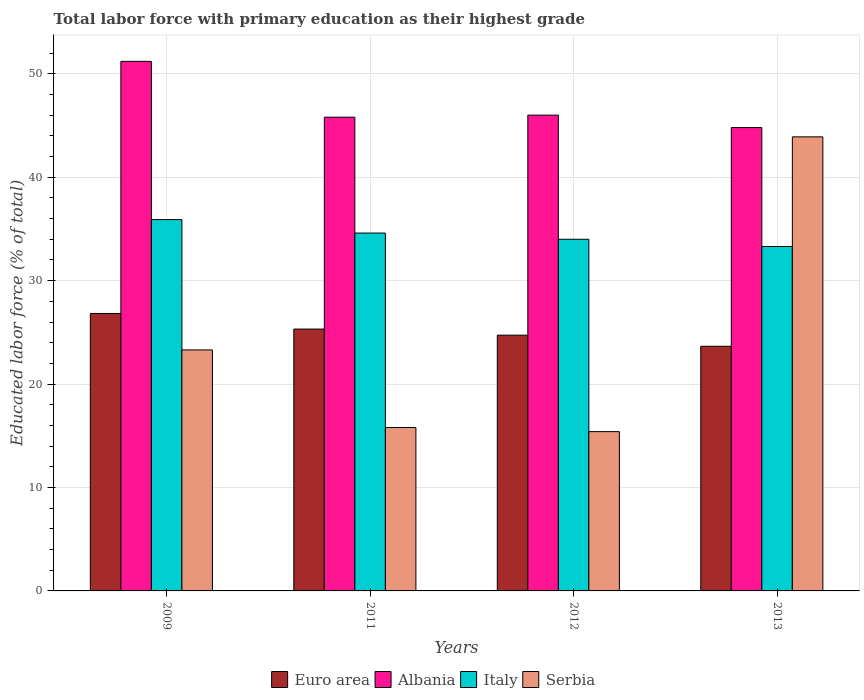How many groups of bars are there?
Make the answer very short. 4. Are the number of bars per tick equal to the number of legend labels?
Provide a succinct answer. Yes. What is the label of the 3rd group of bars from the left?
Your answer should be very brief. 2012. What is the percentage of total labor force with primary education in Serbia in 2009?
Offer a very short reply. 23.3. Across all years, what is the maximum percentage of total labor force with primary education in Serbia?
Give a very brief answer. 43.9. Across all years, what is the minimum percentage of total labor force with primary education in Albania?
Offer a very short reply. 44.8. What is the total percentage of total labor force with primary education in Serbia in the graph?
Provide a succinct answer. 98.4. What is the difference between the percentage of total labor force with primary education in Albania in 2012 and that in 2013?
Your answer should be compact. 1.2. What is the difference between the percentage of total labor force with primary education in Albania in 2011 and the percentage of total labor force with primary education in Euro area in 2009?
Provide a succinct answer. 18.97. What is the average percentage of total labor force with primary education in Italy per year?
Make the answer very short. 34.45. In the year 2009, what is the difference between the percentage of total labor force with primary education in Euro area and percentage of total labor force with primary education in Serbia?
Provide a short and direct response. 3.53. What is the ratio of the percentage of total labor force with primary education in Albania in 2012 to that in 2013?
Ensure brevity in your answer.  1.03. What is the difference between the highest and the second highest percentage of total labor force with primary education in Euro area?
Offer a terse response. 1.51. What is the difference between the highest and the lowest percentage of total labor force with primary education in Serbia?
Ensure brevity in your answer.  28.5. Is it the case that in every year, the sum of the percentage of total labor force with primary education in Serbia and percentage of total labor force with primary education in Euro area is greater than the sum of percentage of total labor force with primary education in Albania and percentage of total labor force with primary education in Italy?
Offer a very short reply. Yes. What does the 3rd bar from the left in 2012 represents?
Give a very brief answer. Italy. What does the 3rd bar from the right in 2012 represents?
Make the answer very short. Albania. Is it the case that in every year, the sum of the percentage of total labor force with primary education in Italy and percentage of total labor force with primary education in Albania is greater than the percentage of total labor force with primary education in Euro area?
Offer a terse response. Yes. How many bars are there?
Your answer should be compact. 16. What is the difference between two consecutive major ticks on the Y-axis?
Give a very brief answer. 10. Does the graph contain any zero values?
Make the answer very short. No. Does the graph contain grids?
Offer a very short reply. Yes. Where does the legend appear in the graph?
Give a very brief answer. Bottom center. How many legend labels are there?
Your answer should be compact. 4. How are the legend labels stacked?
Your answer should be compact. Horizontal. What is the title of the graph?
Give a very brief answer. Total labor force with primary education as their highest grade. Does "Low income" appear as one of the legend labels in the graph?
Keep it short and to the point. No. What is the label or title of the Y-axis?
Ensure brevity in your answer.  Educated labor force (% of total). What is the Educated labor force (% of total) of Euro area in 2009?
Ensure brevity in your answer.  26.83. What is the Educated labor force (% of total) of Albania in 2009?
Make the answer very short. 51.2. What is the Educated labor force (% of total) of Italy in 2009?
Provide a succinct answer. 35.9. What is the Educated labor force (% of total) in Serbia in 2009?
Your answer should be very brief. 23.3. What is the Educated labor force (% of total) of Euro area in 2011?
Provide a succinct answer. 25.32. What is the Educated labor force (% of total) in Albania in 2011?
Your response must be concise. 45.8. What is the Educated labor force (% of total) in Italy in 2011?
Give a very brief answer. 34.6. What is the Educated labor force (% of total) of Serbia in 2011?
Offer a terse response. 15.8. What is the Educated labor force (% of total) of Euro area in 2012?
Provide a short and direct response. 24.73. What is the Educated labor force (% of total) in Italy in 2012?
Give a very brief answer. 34. What is the Educated labor force (% of total) of Serbia in 2012?
Offer a terse response. 15.4. What is the Educated labor force (% of total) in Euro area in 2013?
Keep it short and to the point. 23.65. What is the Educated labor force (% of total) of Albania in 2013?
Your answer should be very brief. 44.8. What is the Educated labor force (% of total) of Italy in 2013?
Offer a very short reply. 33.3. What is the Educated labor force (% of total) of Serbia in 2013?
Your response must be concise. 43.9. Across all years, what is the maximum Educated labor force (% of total) in Euro area?
Give a very brief answer. 26.83. Across all years, what is the maximum Educated labor force (% of total) in Albania?
Your answer should be very brief. 51.2. Across all years, what is the maximum Educated labor force (% of total) of Italy?
Your answer should be compact. 35.9. Across all years, what is the maximum Educated labor force (% of total) of Serbia?
Offer a very short reply. 43.9. Across all years, what is the minimum Educated labor force (% of total) of Euro area?
Provide a short and direct response. 23.65. Across all years, what is the minimum Educated labor force (% of total) of Albania?
Make the answer very short. 44.8. Across all years, what is the minimum Educated labor force (% of total) in Italy?
Offer a terse response. 33.3. Across all years, what is the minimum Educated labor force (% of total) in Serbia?
Ensure brevity in your answer.  15.4. What is the total Educated labor force (% of total) in Euro area in the graph?
Offer a very short reply. 100.52. What is the total Educated labor force (% of total) in Albania in the graph?
Your response must be concise. 187.8. What is the total Educated labor force (% of total) in Italy in the graph?
Provide a succinct answer. 137.8. What is the total Educated labor force (% of total) in Serbia in the graph?
Provide a succinct answer. 98.4. What is the difference between the Educated labor force (% of total) of Euro area in 2009 and that in 2011?
Your response must be concise. 1.51. What is the difference between the Educated labor force (% of total) of Albania in 2009 and that in 2011?
Keep it short and to the point. 5.4. What is the difference between the Educated labor force (% of total) of Italy in 2009 and that in 2011?
Ensure brevity in your answer.  1.3. What is the difference between the Educated labor force (% of total) of Serbia in 2009 and that in 2011?
Ensure brevity in your answer.  7.5. What is the difference between the Educated labor force (% of total) in Euro area in 2009 and that in 2012?
Provide a short and direct response. 2.1. What is the difference between the Educated labor force (% of total) in Italy in 2009 and that in 2012?
Your response must be concise. 1.9. What is the difference between the Educated labor force (% of total) of Euro area in 2009 and that in 2013?
Offer a very short reply. 3.17. What is the difference between the Educated labor force (% of total) of Albania in 2009 and that in 2013?
Offer a terse response. 6.4. What is the difference between the Educated labor force (% of total) of Italy in 2009 and that in 2013?
Provide a short and direct response. 2.6. What is the difference between the Educated labor force (% of total) in Serbia in 2009 and that in 2013?
Your response must be concise. -20.6. What is the difference between the Educated labor force (% of total) of Euro area in 2011 and that in 2012?
Make the answer very short. 0.59. What is the difference between the Educated labor force (% of total) in Euro area in 2011 and that in 2013?
Provide a succinct answer. 1.66. What is the difference between the Educated labor force (% of total) in Albania in 2011 and that in 2013?
Offer a very short reply. 1. What is the difference between the Educated labor force (% of total) of Italy in 2011 and that in 2013?
Your response must be concise. 1.3. What is the difference between the Educated labor force (% of total) of Serbia in 2011 and that in 2013?
Make the answer very short. -28.1. What is the difference between the Educated labor force (% of total) of Euro area in 2012 and that in 2013?
Your response must be concise. 1.07. What is the difference between the Educated labor force (% of total) in Serbia in 2012 and that in 2013?
Your answer should be compact. -28.5. What is the difference between the Educated labor force (% of total) in Euro area in 2009 and the Educated labor force (% of total) in Albania in 2011?
Your answer should be compact. -18.97. What is the difference between the Educated labor force (% of total) of Euro area in 2009 and the Educated labor force (% of total) of Italy in 2011?
Give a very brief answer. -7.77. What is the difference between the Educated labor force (% of total) of Euro area in 2009 and the Educated labor force (% of total) of Serbia in 2011?
Keep it short and to the point. 11.03. What is the difference between the Educated labor force (% of total) in Albania in 2009 and the Educated labor force (% of total) in Italy in 2011?
Offer a terse response. 16.6. What is the difference between the Educated labor force (% of total) of Albania in 2009 and the Educated labor force (% of total) of Serbia in 2011?
Your answer should be very brief. 35.4. What is the difference between the Educated labor force (% of total) in Italy in 2009 and the Educated labor force (% of total) in Serbia in 2011?
Ensure brevity in your answer.  20.1. What is the difference between the Educated labor force (% of total) in Euro area in 2009 and the Educated labor force (% of total) in Albania in 2012?
Offer a terse response. -19.17. What is the difference between the Educated labor force (% of total) in Euro area in 2009 and the Educated labor force (% of total) in Italy in 2012?
Make the answer very short. -7.17. What is the difference between the Educated labor force (% of total) in Euro area in 2009 and the Educated labor force (% of total) in Serbia in 2012?
Offer a very short reply. 11.43. What is the difference between the Educated labor force (% of total) of Albania in 2009 and the Educated labor force (% of total) of Italy in 2012?
Give a very brief answer. 17.2. What is the difference between the Educated labor force (% of total) of Albania in 2009 and the Educated labor force (% of total) of Serbia in 2012?
Offer a very short reply. 35.8. What is the difference between the Educated labor force (% of total) in Italy in 2009 and the Educated labor force (% of total) in Serbia in 2012?
Your answer should be compact. 20.5. What is the difference between the Educated labor force (% of total) of Euro area in 2009 and the Educated labor force (% of total) of Albania in 2013?
Keep it short and to the point. -17.97. What is the difference between the Educated labor force (% of total) of Euro area in 2009 and the Educated labor force (% of total) of Italy in 2013?
Offer a very short reply. -6.47. What is the difference between the Educated labor force (% of total) in Euro area in 2009 and the Educated labor force (% of total) in Serbia in 2013?
Offer a very short reply. -17.07. What is the difference between the Educated labor force (% of total) of Albania in 2009 and the Educated labor force (% of total) of Italy in 2013?
Your answer should be very brief. 17.9. What is the difference between the Educated labor force (% of total) in Albania in 2009 and the Educated labor force (% of total) in Serbia in 2013?
Provide a succinct answer. 7.3. What is the difference between the Educated labor force (% of total) in Euro area in 2011 and the Educated labor force (% of total) in Albania in 2012?
Offer a very short reply. -20.68. What is the difference between the Educated labor force (% of total) of Euro area in 2011 and the Educated labor force (% of total) of Italy in 2012?
Offer a very short reply. -8.68. What is the difference between the Educated labor force (% of total) of Euro area in 2011 and the Educated labor force (% of total) of Serbia in 2012?
Provide a succinct answer. 9.92. What is the difference between the Educated labor force (% of total) in Albania in 2011 and the Educated labor force (% of total) in Italy in 2012?
Your answer should be very brief. 11.8. What is the difference between the Educated labor force (% of total) of Albania in 2011 and the Educated labor force (% of total) of Serbia in 2012?
Offer a very short reply. 30.4. What is the difference between the Educated labor force (% of total) in Italy in 2011 and the Educated labor force (% of total) in Serbia in 2012?
Provide a short and direct response. 19.2. What is the difference between the Educated labor force (% of total) of Euro area in 2011 and the Educated labor force (% of total) of Albania in 2013?
Your answer should be very brief. -19.48. What is the difference between the Educated labor force (% of total) in Euro area in 2011 and the Educated labor force (% of total) in Italy in 2013?
Offer a very short reply. -7.98. What is the difference between the Educated labor force (% of total) of Euro area in 2011 and the Educated labor force (% of total) of Serbia in 2013?
Offer a terse response. -18.58. What is the difference between the Educated labor force (% of total) of Albania in 2011 and the Educated labor force (% of total) of Italy in 2013?
Give a very brief answer. 12.5. What is the difference between the Educated labor force (% of total) of Italy in 2011 and the Educated labor force (% of total) of Serbia in 2013?
Provide a short and direct response. -9.3. What is the difference between the Educated labor force (% of total) of Euro area in 2012 and the Educated labor force (% of total) of Albania in 2013?
Your answer should be very brief. -20.07. What is the difference between the Educated labor force (% of total) in Euro area in 2012 and the Educated labor force (% of total) in Italy in 2013?
Offer a terse response. -8.57. What is the difference between the Educated labor force (% of total) in Euro area in 2012 and the Educated labor force (% of total) in Serbia in 2013?
Make the answer very short. -19.17. What is the difference between the Educated labor force (% of total) in Albania in 2012 and the Educated labor force (% of total) in Serbia in 2013?
Offer a very short reply. 2.1. What is the average Educated labor force (% of total) in Euro area per year?
Keep it short and to the point. 25.13. What is the average Educated labor force (% of total) in Albania per year?
Ensure brevity in your answer.  46.95. What is the average Educated labor force (% of total) of Italy per year?
Make the answer very short. 34.45. What is the average Educated labor force (% of total) in Serbia per year?
Your answer should be very brief. 24.6. In the year 2009, what is the difference between the Educated labor force (% of total) of Euro area and Educated labor force (% of total) of Albania?
Your response must be concise. -24.37. In the year 2009, what is the difference between the Educated labor force (% of total) in Euro area and Educated labor force (% of total) in Italy?
Your answer should be compact. -9.07. In the year 2009, what is the difference between the Educated labor force (% of total) of Euro area and Educated labor force (% of total) of Serbia?
Offer a terse response. 3.53. In the year 2009, what is the difference between the Educated labor force (% of total) in Albania and Educated labor force (% of total) in Italy?
Make the answer very short. 15.3. In the year 2009, what is the difference between the Educated labor force (% of total) of Albania and Educated labor force (% of total) of Serbia?
Ensure brevity in your answer.  27.9. In the year 2011, what is the difference between the Educated labor force (% of total) of Euro area and Educated labor force (% of total) of Albania?
Keep it short and to the point. -20.48. In the year 2011, what is the difference between the Educated labor force (% of total) of Euro area and Educated labor force (% of total) of Italy?
Provide a short and direct response. -9.28. In the year 2011, what is the difference between the Educated labor force (% of total) in Euro area and Educated labor force (% of total) in Serbia?
Make the answer very short. 9.52. In the year 2012, what is the difference between the Educated labor force (% of total) in Euro area and Educated labor force (% of total) in Albania?
Make the answer very short. -21.27. In the year 2012, what is the difference between the Educated labor force (% of total) of Euro area and Educated labor force (% of total) of Italy?
Make the answer very short. -9.27. In the year 2012, what is the difference between the Educated labor force (% of total) in Euro area and Educated labor force (% of total) in Serbia?
Give a very brief answer. 9.33. In the year 2012, what is the difference between the Educated labor force (% of total) of Albania and Educated labor force (% of total) of Serbia?
Offer a very short reply. 30.6. In the year 2012, what is the difference between the Educated labor force (% of total) of Italy and Educated labor force (% of total) of Serbia?
Provide a succinct answer. 18.6. In the year 2013, what is the difference between the Educated labor force (% of total) of Euro area and Educated labor force (% of total) of Albania?
Offer a terse response. -21.15. In the year 2013, what is the difference between the Educated labor force (% of total) in Euro area and Educated labor force (% of total) in Italy?
Ensure brevity in your answer.  -9.65. In the year 2013, what is the difference between the Educated labor force (% of total) of Euro area and Educated labor force (% of total) of Serbia?
Make the answer very short. -20.25. In the year 2013, what is the difference between the Educated labor force (% of total) of Albania and Educated labor force (% of total) of Italy?
Keep it short and to the point. 11.5. In the year 2013, what is the difference between the Educated labor force (% of total) of Albania and Educated labor force (% of total) of Serbia?
Your answer should be very brief. 0.9. In the year 2013, what is the difference between the Educated labor force (% of total) of Italy and Educated labor force (% of total) of Serbia?
Your response must be concise. -10.6. What is the ratio of the Educated labor force (% of total) of Euro area in 2009 to that in 2011?
Ensure brevity in your answer.  1.06. What is the ratio of the Educated labor force (% of total) in Albania in 2009 to that in 2011?
Provide a succinct answer. 1.12. What is the ratio of the Educated labor force (% of total) of Italy in 2009 to that in 2011?
Keep it short and to the point. 1.04. What is the ratio of the Educated labor force (% of total) in Serbia in 2009 to that in 2011?
Give a very brief answer. 1.47. What is the ratio of the Educated labor force (% of total) of Euro area in 2009 to that in 2012?
Your answer should be very brief. 1.08. What is the ratio of the Educated labor force (% of total) of Albania in 2009 to that in 2012?
Offer a terse response. 1.11. What is the ratio of the Educated labor force (% of total) of Italy in 2009 to that in 2012?
Offer a terse response. 1.06. What is the ratio of the Educated labor force (% of total) of Serbia in 2009 to that in 2012?
Offer a very short reply. 1.51. What is the ratio of the Educated labor force (% of total) in Euro area in 2009 to that in 2013?
Give a very brief answer. 1.13. What is the ratio of the Educated labor force (% of total) of Albania in 2009 to that in 2013?
Ensure brevity in your answer.  1.14. What is the ratio of the Educated labor force (% of total) in Italy in 2009 to that in 2013?
Give a very brief answer. 1.08. What is the ratio of the Educated labor force (% of total) of Serbia in 2009 to that in 2013?
Keep it short and to the point. 0.53. What is the ratio of the Educated labor force (% of total) in Euro area in 2011 to that in 2012?
Your answer should be very brief. 1.02. What is the ratio of the Educated labor force (% of total) of Albania in 2011 to that in 2012?
Ensure brevity in your answer.  1. What is the ratio of the Educated labor force (% of total) in Italy in 2011 to that in 2012?
Offer a very short reply. 1.02. What is the ratio of the Educated labor force (% of total) in Euro area in 2011 to that in 2013?
Your answer should be compact. 1.07. What is the ratio of the Educated labor force (% of total) of Albania in 2011 to that in 2013?
Provide a succinct answer. 1.02. What is the ratio of the Educated labor force (% of total) of Italy in 2011 to that in 2013?
Give a very brief answer. 1.04. What is the ratio of the Educated labor force (% of total) in Serbia in 2011 to that in 2013?
Make the answer very short. 0.36. What is the ratio of the Educated labor force (% of total) in Euro area in 2012 to that in 2013?
Offer a terse response. 1.05. What is the ratio of the Educated labor force (% of total) in Albania in 2012 to that in 2013?
Make the answer very short. 1.03. What is the ratio of the Educated labor force (% of total) of Italy in 2012 to that in 2013?
Your response must be concise. 1.02. What is the ratio of the Educated labor force (% of total) in Serbia in 2012 to that in 2013?
Provide a succinct answer. 0.35. What is the difference between the highest and the second highest Educated labor force (% of total) in Euro area?
Make the answer very short. 1.51. What is the difference between the highest and the second highest Educated labor force (% of total) of Albania?
Give a very brief answer. 5.2. What is the difference between the highest and the second highest Educated labor force (% of total) in Serbia?
Provide a succinct answer. 20.6. What is the difference between the highest and the lowest Educated labor force (% of total) of Euro area?
Your answer should be compact. 3.17. What is the difference between the highest and the lowest Educated labor force (% of total) in Italy?
Your answer should be very brief. 2.6. What is the difference between the highest and the lowest Educated labor force (% of total) in Serbia?
Your answer should be very brief. 28.5. 